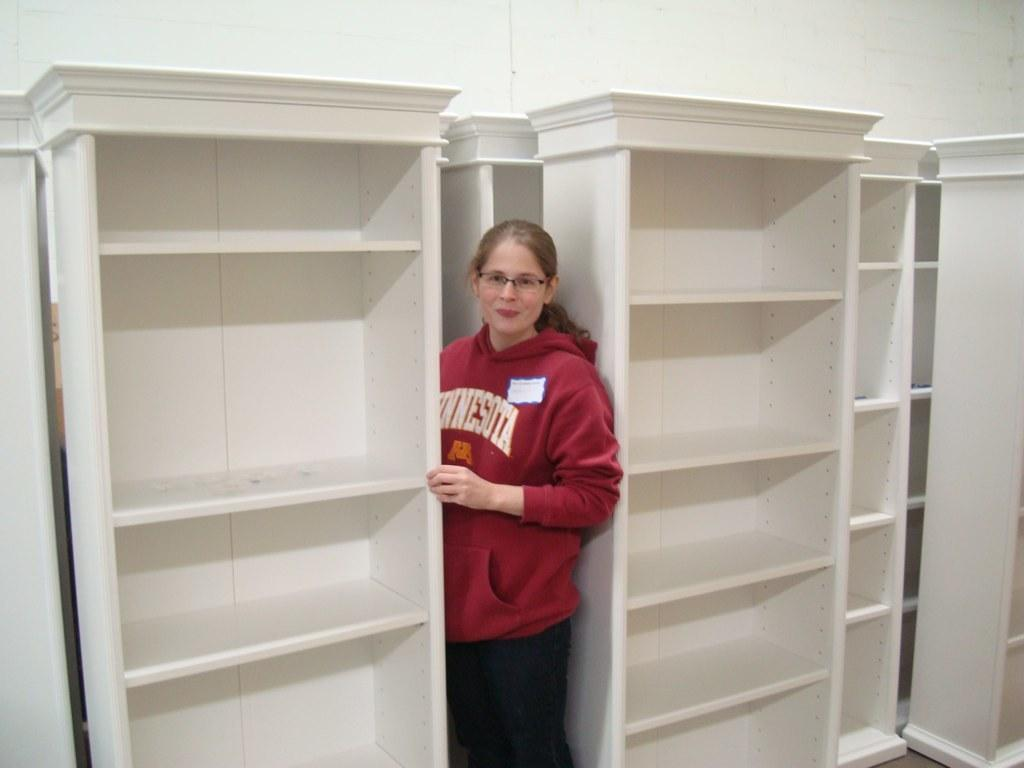Who is present in the image? There is a woman in the image. What is the woman doing in the image? The woman is standing in between shelves. What riddle is the woman trying to solve in the image? There is no riddle present in the image, and the woman's actions do not suggest she is trying to solve a riddle. 